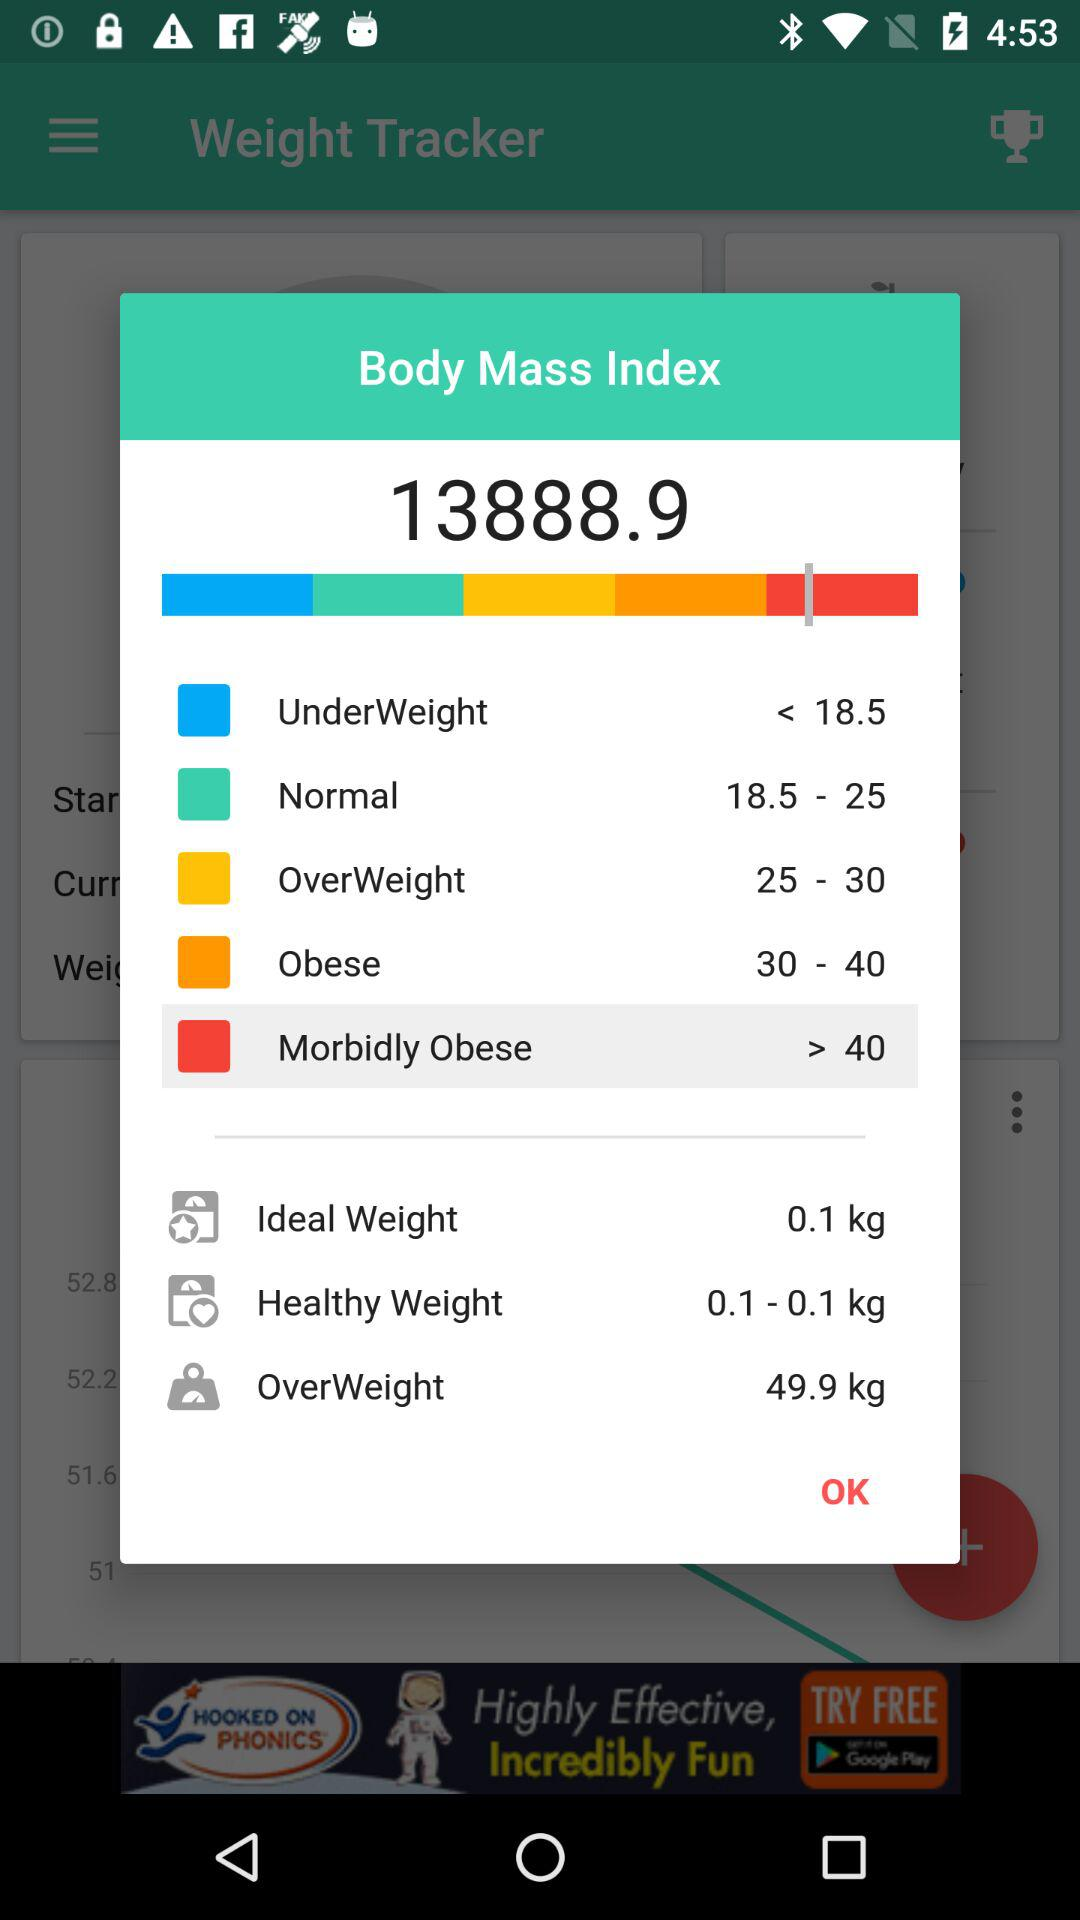What is the value of OverWeight? The value of OverWeight is 49.9 kg. 